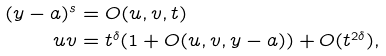Convert formula to latex. <formula><loc_0><loc_0><loc_500><loc_500>( y - a ) ^ { s } & = O ( u , v , t ) \\ u v & = t ^ { \delta } ( 1 + O ( u , v , y - a ) ) + O ( t ^ { 2 \delta } ) ,</formula> 